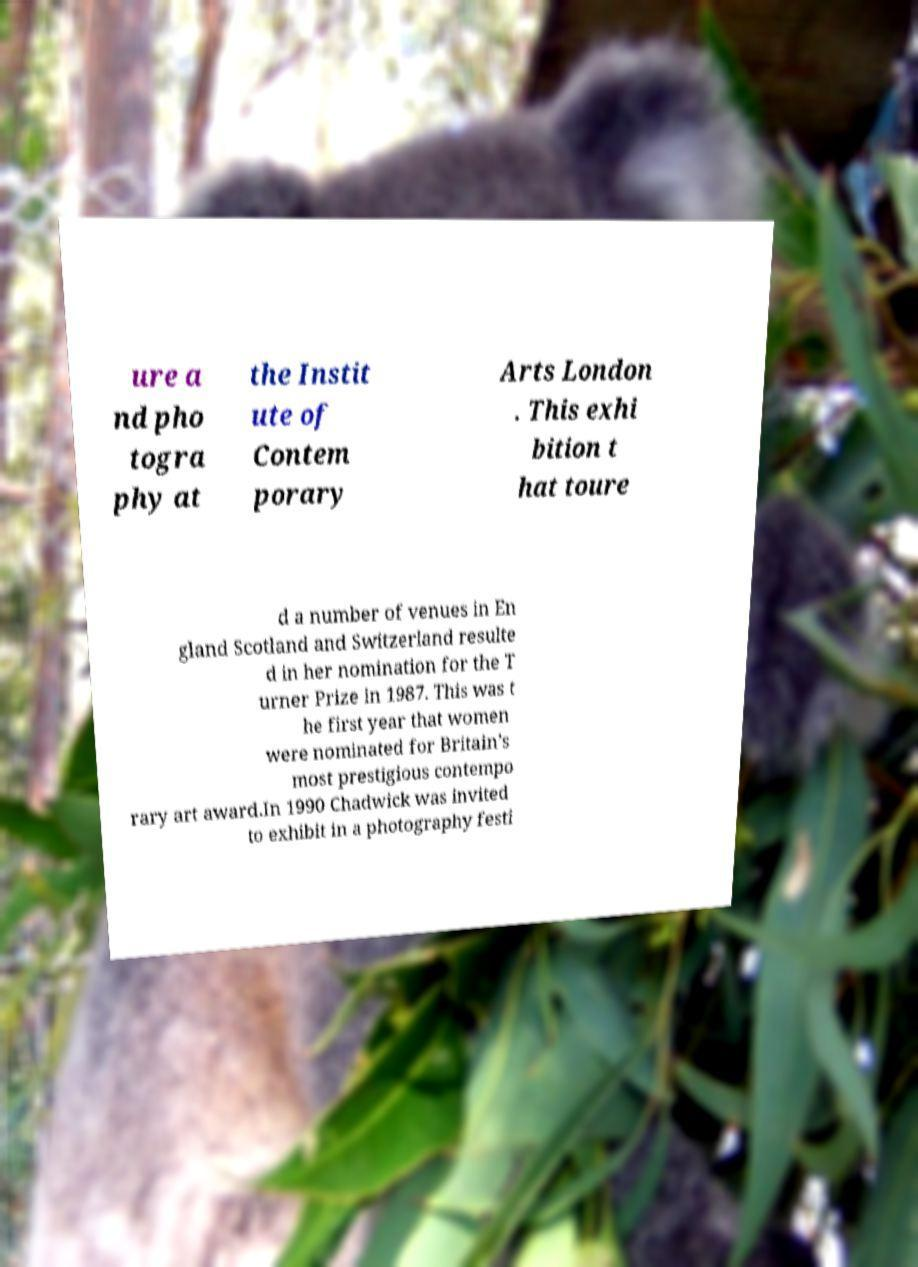There's text embedded in this image that I need extracted. Can you transcribe it verbatim? ure a nd pho togra phy at the Instit ute of Contem porary Arts London . This exhi bition t hat toure d a number of venues in En gland Scotland and Switzerland resulte d in her nomination for the T urner Prize in 1987. This was t he first year that women were nominated for Britain’s most prestigious contempo rary art award.In 1990 Chadwick was invited to exhibit in a photography festi 